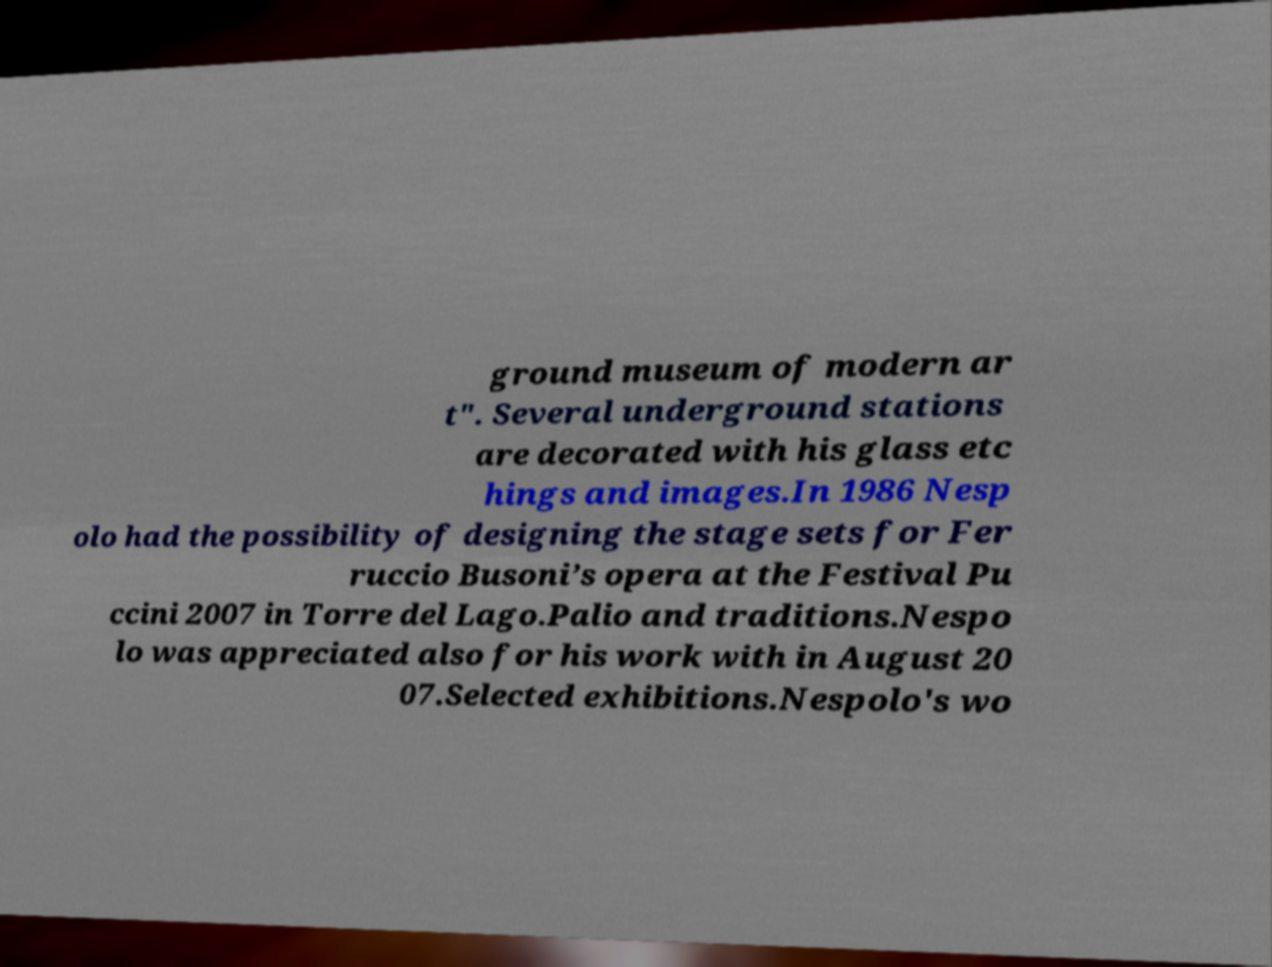Can you accurately transcribe the text from the provided image for me? ground museum of modern ar t". Several underground stations are decorated with his glass etc hings and images.In 1986 Nesp olo had the possibility of designing the stage sets for Fer ruccio Busoni’s opera at the Festival Pu ccini 2007 in Torre del Lago.Palio and traditions.Nespo lo was appreciated also for his work with in August 20 07.Selected exhibitions.Nespolo's wo 